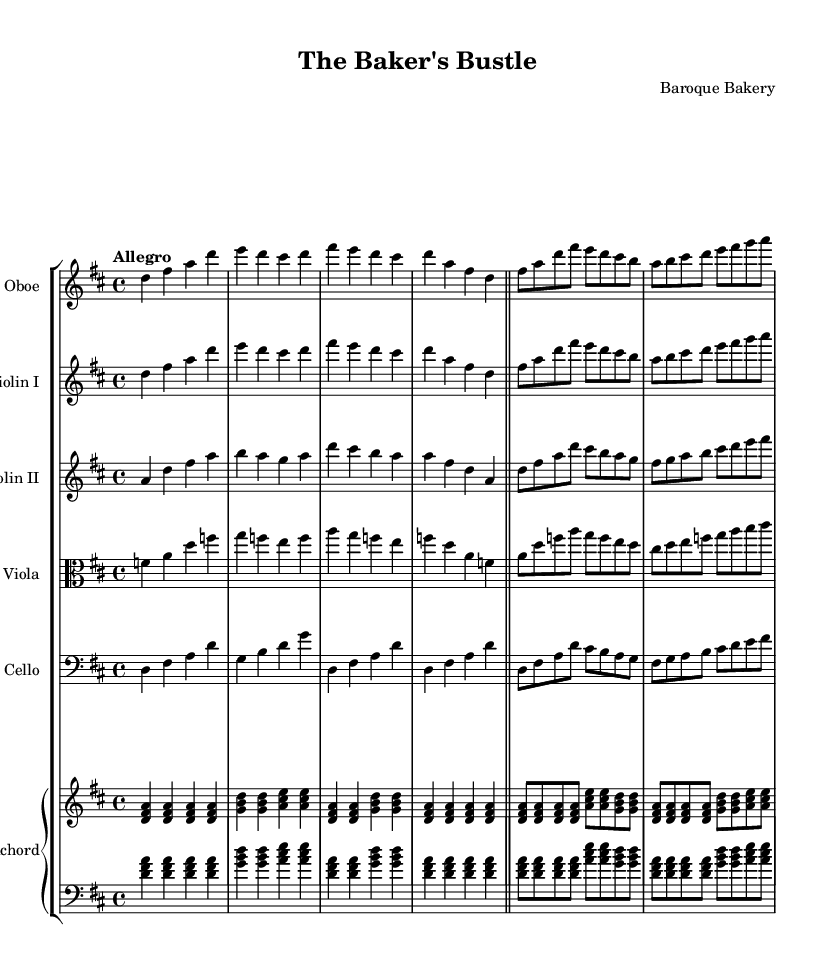What is the key signature of this music? The key signature is indicated by the number of sharps or flats at the beginning of the staff. In this case, there are two sharps (F# and C#), which defines the key signature as D major.
Answer: D major What is the time signature of this music? The time signature is found at the beginning of the piece, just after the key signature. The notation shows a 4 over 4, indicating that there are four beats in a measure and the quarter note receives one beat.
Answer: 4/4 What is the tempo marking of this music? The tempo marking is usually written above the staff at the beginning of the piece. Here, it states "Allegro," which defines the speed of the music.
Answer: Allegro Which instruments are featured in this orchestral suite? The instruments are listed at the beginning of each staff. The suite includes Oboe, Violin I, Violin II, Viola, Cello, and Harpsichord.
Answer: Oboe, Violin I, Violin II, Viola, Cello, Harpsichord Is this music composed in a major or minor key? By analyzing the key signature (D major) and the melodic qualities in the piece, one can determine that it is composed in a major key, as major keys have a more bright and cheerful tonality compared to minor keys.
Answer: Major Which section of the bakery does the music evoke with its orchestration? The orchestration combines lively melodies and harmonies characteristic of a bustling environment in a bakery. The interplay among instruments creates a sense of activity as one imagines the hustle of baking and serving.
Answer: Busy bakery How many measures are in the first section of the music? By counting the vertical bar lines that indicate the end of each measure in the first section, you can determine the total number of measures. Here, I observe eight measures before the double bar line.
Answer: Eight measures 